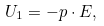<formula> <loc_0><loc_0><loc_500><loc_500>U _ { 1 } = - { p } \cdot { E } ,</formula> 